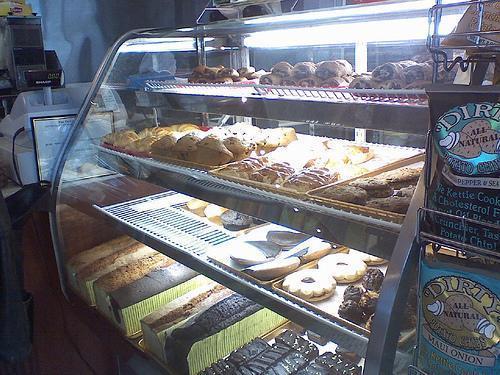How many bags of chips?
Give a very brief answer. 2. How many shelves are in the display case?
Give a very brief answer. 4. How many chocolate items are in the case?
Give a very brief answer. 5. 